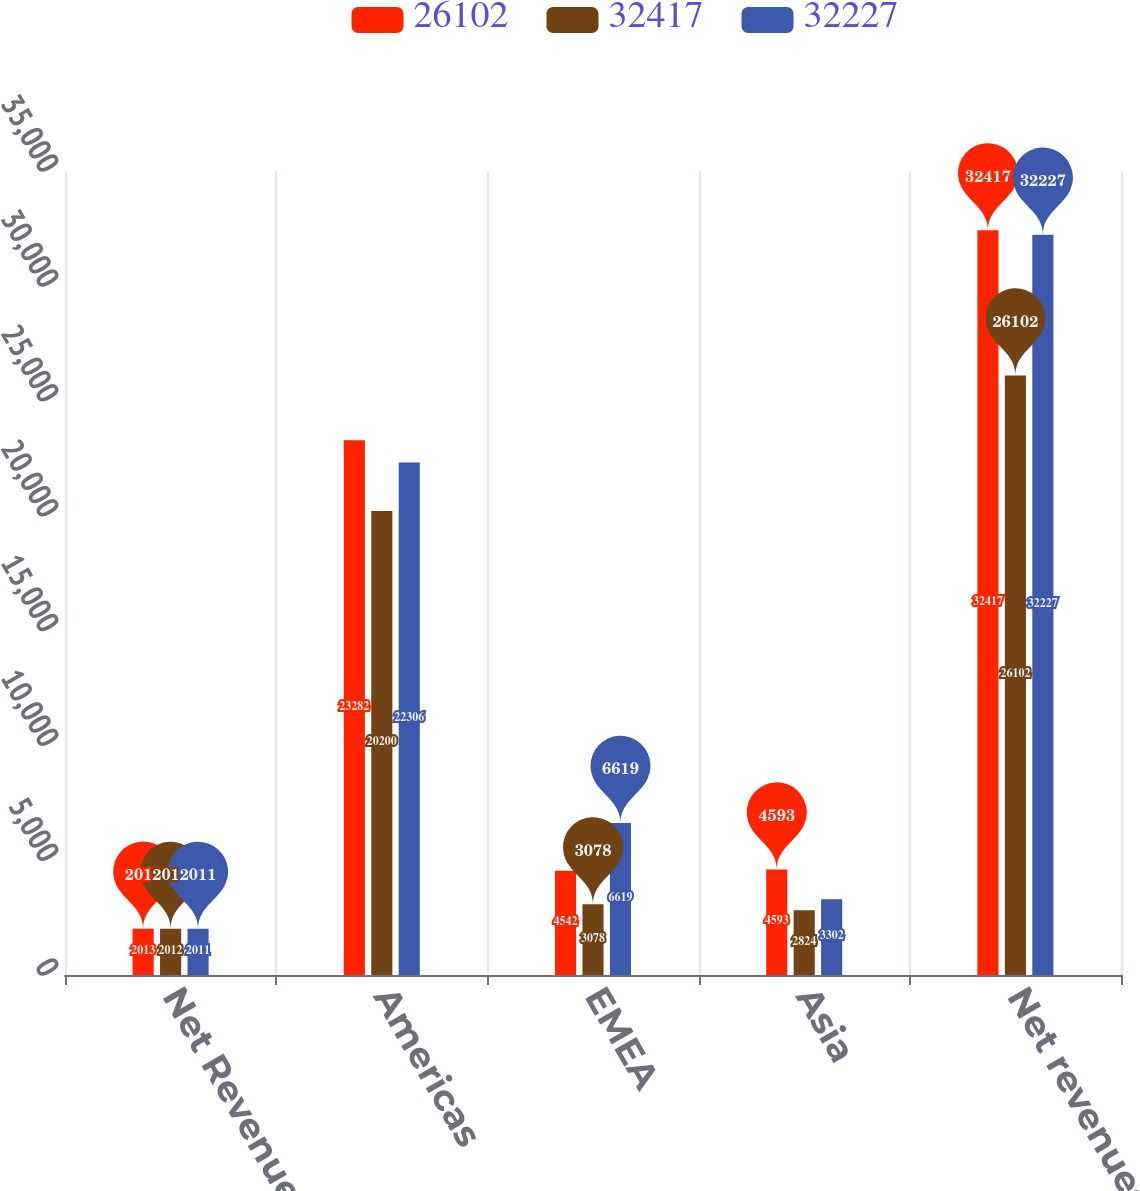<chart> <loc_0><loc_0><loc_500><loc_500><stacked_bar_chart><ecel><fcel>Net Revenues<fcel>Americas<fcel>EMEA<fcel>Asia<fcel>Net revenues<nl><fcel>26102<fcel>2013<fcel>23282<fcel>4542<fcel>4593<fcel>32417<nl><fcel>32417<fcel>2012<fcel>20200<fcel>3078<fcel>2824<fcel>26102<nl><fcel>32227<fcel>2011<fcel>22306<fcel>6619<fcel>3302<fcel>32227<nl></chart> 